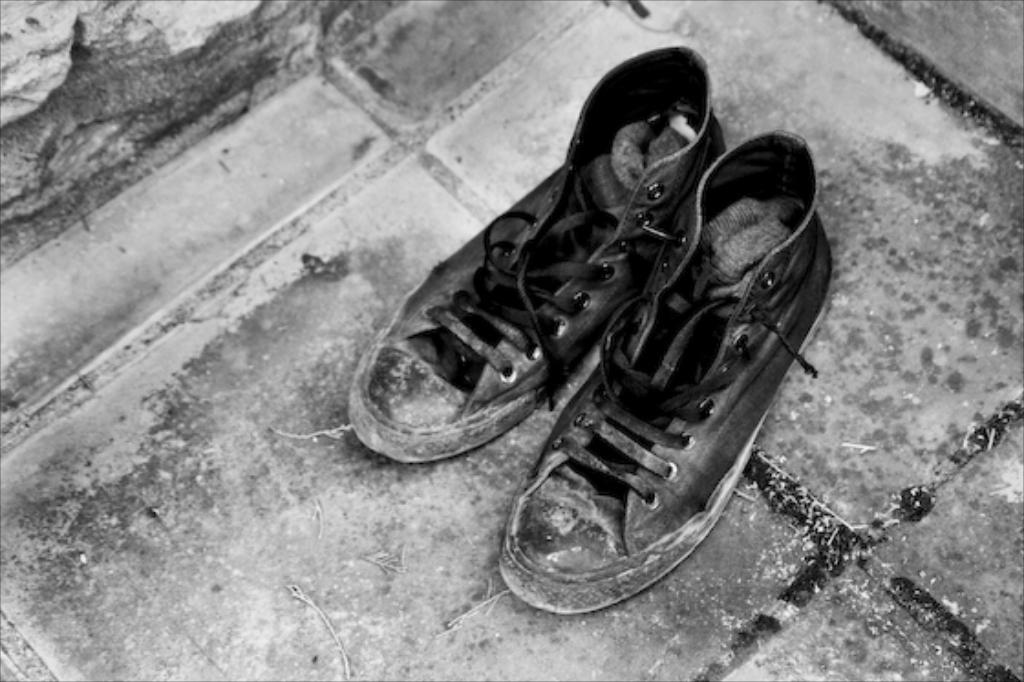What is the color scheme of the image? The image is black and white. What objects are visible in the image? There are shoes in the image. Where are the shoes located? The shoes are on a platform. What type of beef is being prepared on the platform in the image? There is no beef or any indication of food preparation in the image; it only features shoes on a platform. 